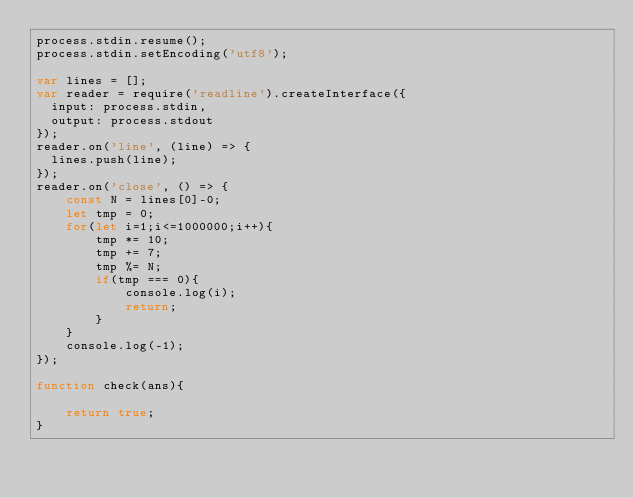Convert code to text. <code><loc_0><loc_0><loc_500><loc_500><_JavaScript_>process.stdin.resume();
process.stdin.setEncoding('utf8');

var lines = [];
var reader = require('readline').createInterface({
  input: process.stdin,
  output: process.stdout
});
reader.on('line', (line) => {
  lines.push(line);
});
reader.on('close', () => {
    const N = lines[0]-0;
    let tmp = 0;
    for(let i=1;i<=1000000;i++){
        tmp *= 10;
        tmp += 7;
        tmp %= N;
        if(tmp === 0){
            console.log(i);
            return;
        }
    }
    console.log(-1);
});

function check(ans){
    
    return true;
}
</code> 